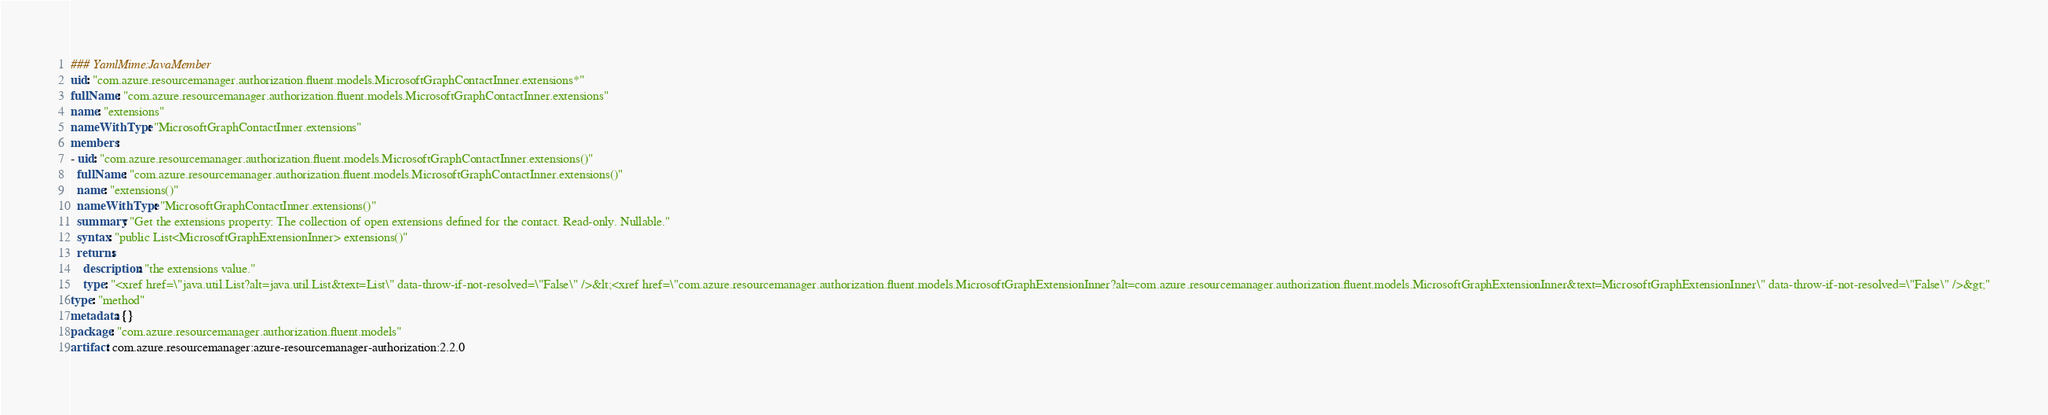<code> <loc_0><loc_0><loc_500><loc_500><_YAML_>### YamlMime:JavaMember
uid: "com.azure.resourcemanager.authorization.fluent.models.MicrosoftGraphContactInner.extensions*"
fullName: "com.azure.resourcemanager.authorization.fluent.models.MicrosoftGraphContactInner.extensions"
name: "extensions"
nameWithType: "MicrosoftGraphContactInner.extensions"
members:
- uid: "com.azure.resourcemanager.authorization.fluent.models.MicrosoftGraphContactInner.extensions()"
  fullName: "com.azure.resourcemanager.authorization.fluent.models.MicrosoftGraphContactInner.extensions()"
  name: "extensions()"
  nameWithType: "MicrosoftGraphContactInner.extensions()"
  summary: "Get the extensions property: The collection of open extensions defined for the contact. Read-only. Nullable."
  syntax: "public List<MicrosoftGraphExtensionInner> extensions()"
  returns:
    description: "the extensions value."
    type: "<xref href=\"java.util.List?alt=java.util.List&text=List\" data-throw-if-not-resolved=\"False\" />&lt;<xref href=\"com.azure.resourcemanager.authorization.fluent.models.MicrosoftGraphExtensionInner?alt=com.azure.resourcemanager.authorization.fluent.models.MicrosoftGraphExtensionInner&text=MicrosoftGraphExtensionInner\" data-throw-if-not-resolved=\"False\" />&gt;"
type: "method"
metadata: {}
package: "com.azure.resourcemanager.authorization.fluent.models"
artifact: com.azure.resourcemanager:azure-resourcemanager-authorization:2.2.0
</code> 